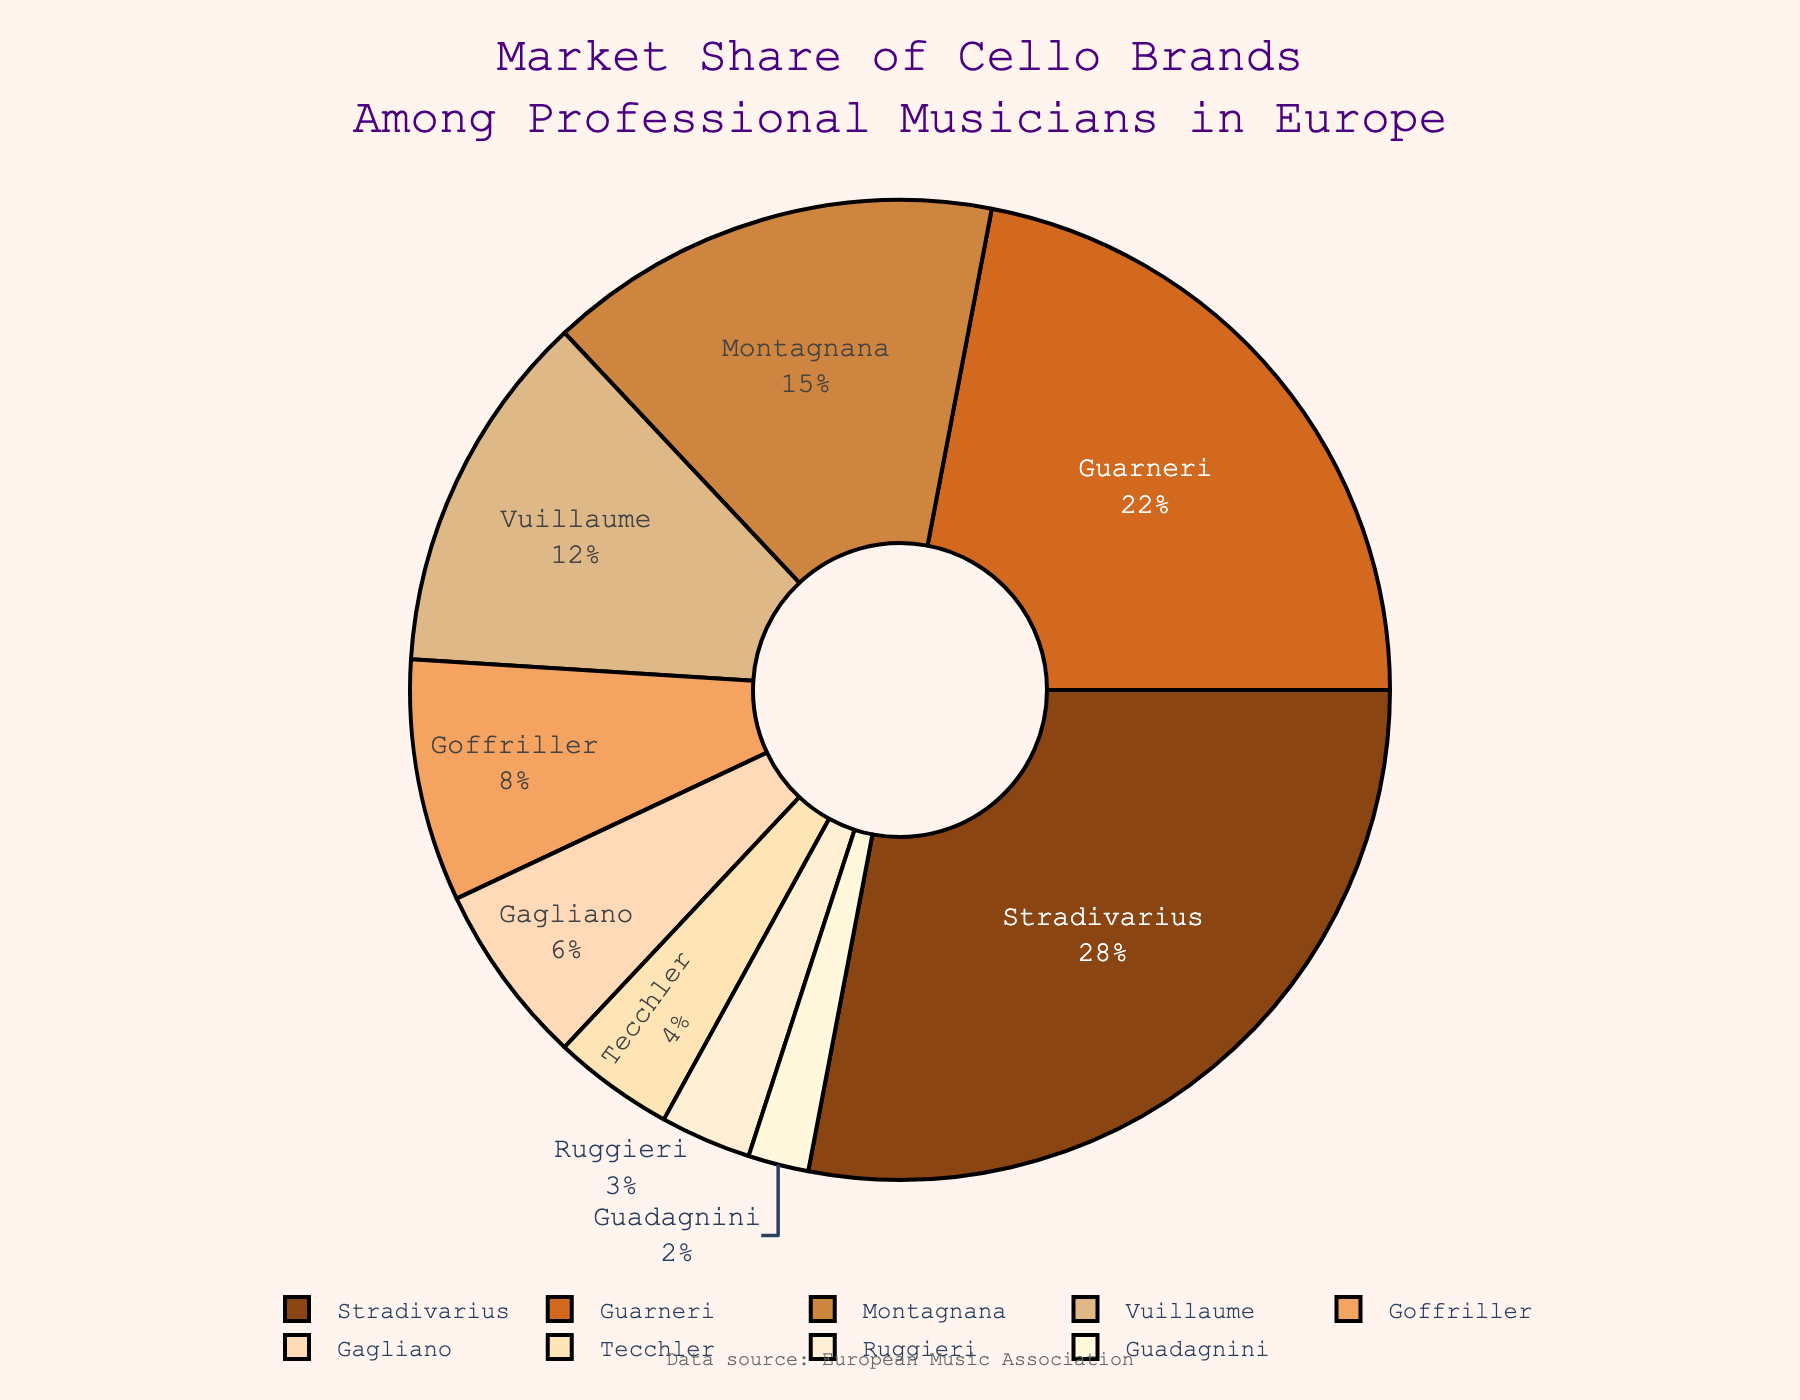What is the most popular cello brand among professional musicians in Europe? The pie chart shows the market share of different cello brands among professional musicians in Europe. By looking at the slices, we can see which brand has the largest share. The Stradivarius brand has the largest slice, indicating it is the most popular.
Answer: Stradivarius What is the combined market share of Guarneri and Montagnana? To find the combined market share, add the percentages of Guarneri and Montagnana. According to the chart, Guarneri has a market share of 22% and Montagnana has 15%. So, 22% + 15% = 37%.
Answer: 37% Which brands have a market share below 5%? Observing the pie chart, identify the slices representing brands with less than 5% market share. The brands Tecchler (4%), Ruggieri (3%), and Guadagnini (2%) all have market shares below 5%.
Answer: Tecchler, Ruggieri, Guadagnini How much greater is the market share of Stradivarius compared to Goffriller? To find this, subtract the market share of Goffriller from Stradivarius. Stradivarius has a market share of 28% and Goffriller has 8%. Therefore, 28% - 8% = 20%.
Answer: 20% What is the smallest market share percentage and which brand does it correspond to? By looking at the smallest slice in the pie chart, you can determine the smallest market share. The Guadagnini brand, with 2%, has the smallest market share.
Answer: Guadagnini, 2% If the market shares of Vuillaume and Tecchler are combined, would they surpass that of Guarneri? First, add the percentages of Vuillaume and Tecchler. Vuillaume has 12% and Tecchler has 4%, so 12% + 4% = 16%. Compare this with Guarneri's market share of 22%. Since 16% is less than 22%, they would not surpass Guarneri.
Answer: No Which two brands together cover over one-third of the market share? To determine this, search for pairs of brands whose combined market share exceeds 33.33%. Adding the shares of Stradivarius (28%) and Guarneri (22%) equals 50%, which is more than one-third. Therefore, these two brands together cover over one-third of the market share.
Answer: Stradivarius and Guarneri How many brands have a market share between 5% and 10%? Check the pie chart for slices representing brands with market shares between 5% and 10%. Goffriller (8%) and Gagliano (6%) fall into this range, totaling two brands.
Answer: 2 What is the total market share of brands other than Stradivarius? To find this, subtract Stradivarius's market share from 100%. Stradivarius has 28%, so 100% - 28% = 72%.
Answer: 72% What percentage of the market do the bottom three brands together account for? Add the market shares of the three brands with the smallest shares: Tecchler (4%), Ruggieri (3%), and Guadagnini (2%). So, 4% + 3% + 2% = 9%.
Answer: 9% 